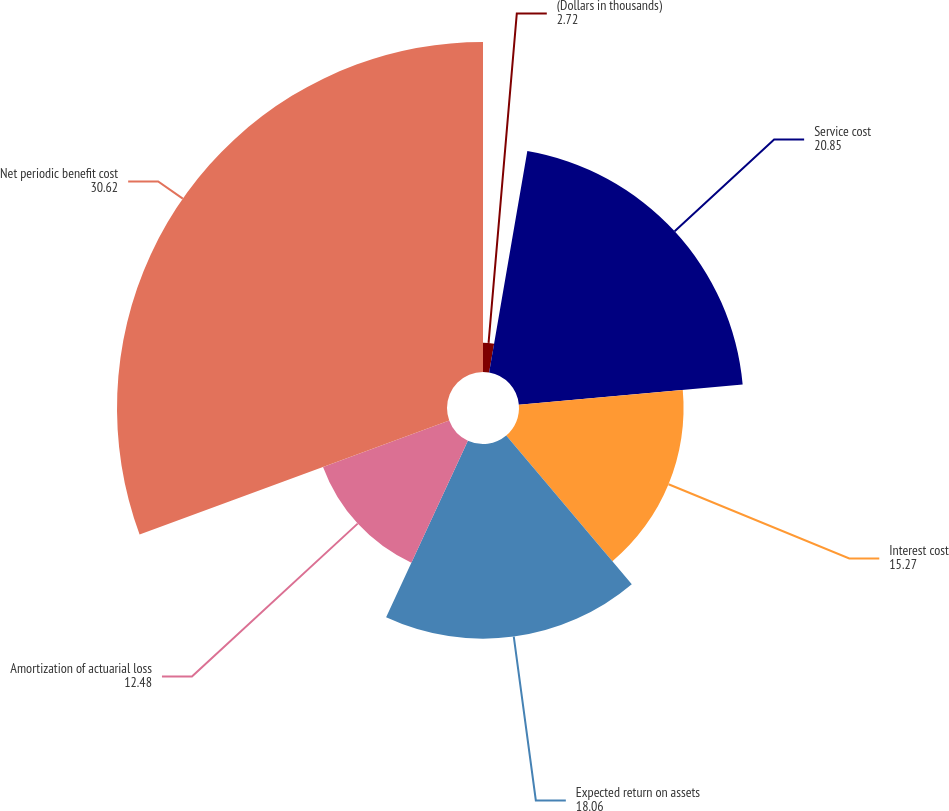Convert chart. <chart><loc_0><loc_0><loc_500><loc_500><pie_chart><fcel>(Dollars in thousands)<fcel>Service cost<fcel>Interest cost<fcel>Expected return on assets<fcel>Amortization of actuarial loss<fcel>Net periodic benefit cost<nl><fcel>2.72%<fcel>20.85%<fcel>15.27%<fcel>18.06%<fcel>12.48%<fcel>30.62%<nl></chart> 